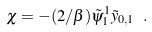<formula> <loc_0><loc_0><loc_500><loc_500>\chi = - ( 2 / \beta ) \tilde { \psi } ^ { 1 } _ { 1 } \tilde { y } _ { 0 , 1 } \ .</formula> 